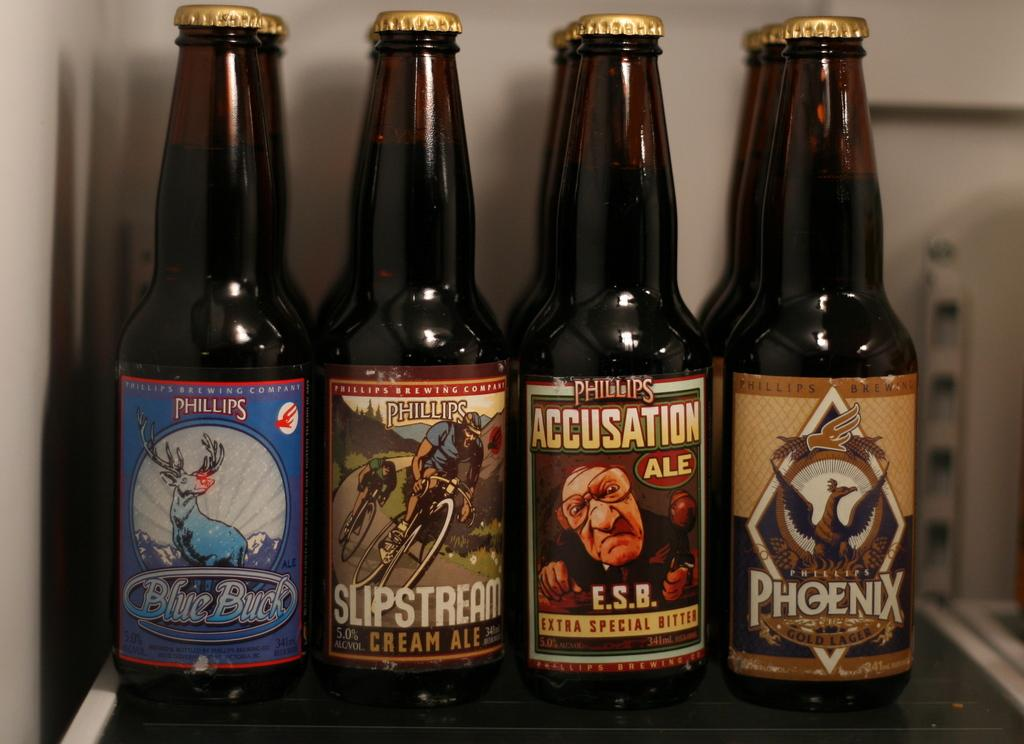<image>
Summarize the visual content of the image. An assortment of Phillips beers are in a refrigerator. 